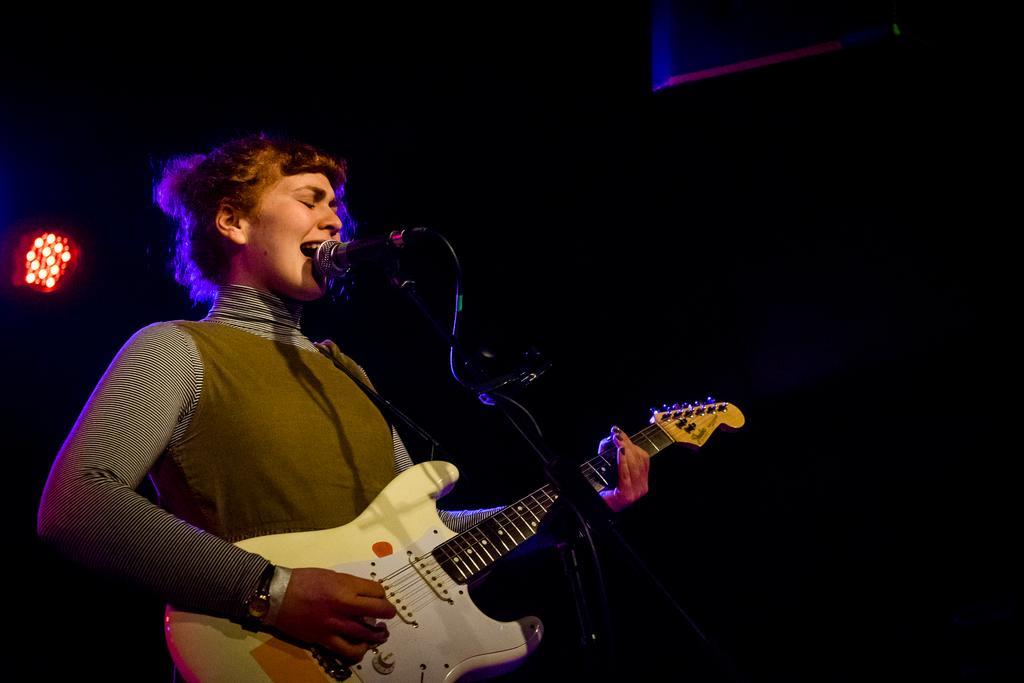Could you give a brief overview of what you see in this image? Girl playing guitar,this is microphone and in the back there is light. 